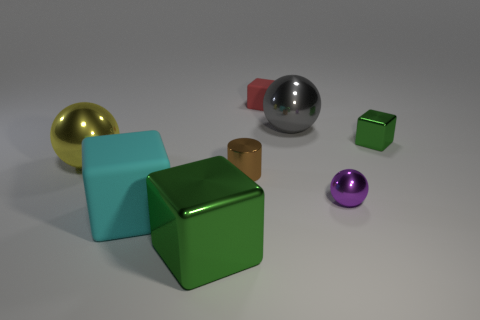Subtract all tiny green cubes. How many cubes are left? 3 Add 1 brown cylinders. How many objects exist? 9 Subtract all balls. How many objects are left? 5 Subtract all green metallic objects. Subtract all small brown objects. How many objects are left? 5 Add 1 small cubes. How many small cubes are left? 3 Add 3 big gray blocks. How many big gray blocks exist? 3 Subtract 0 blue blocks. How many objects are left? 8 